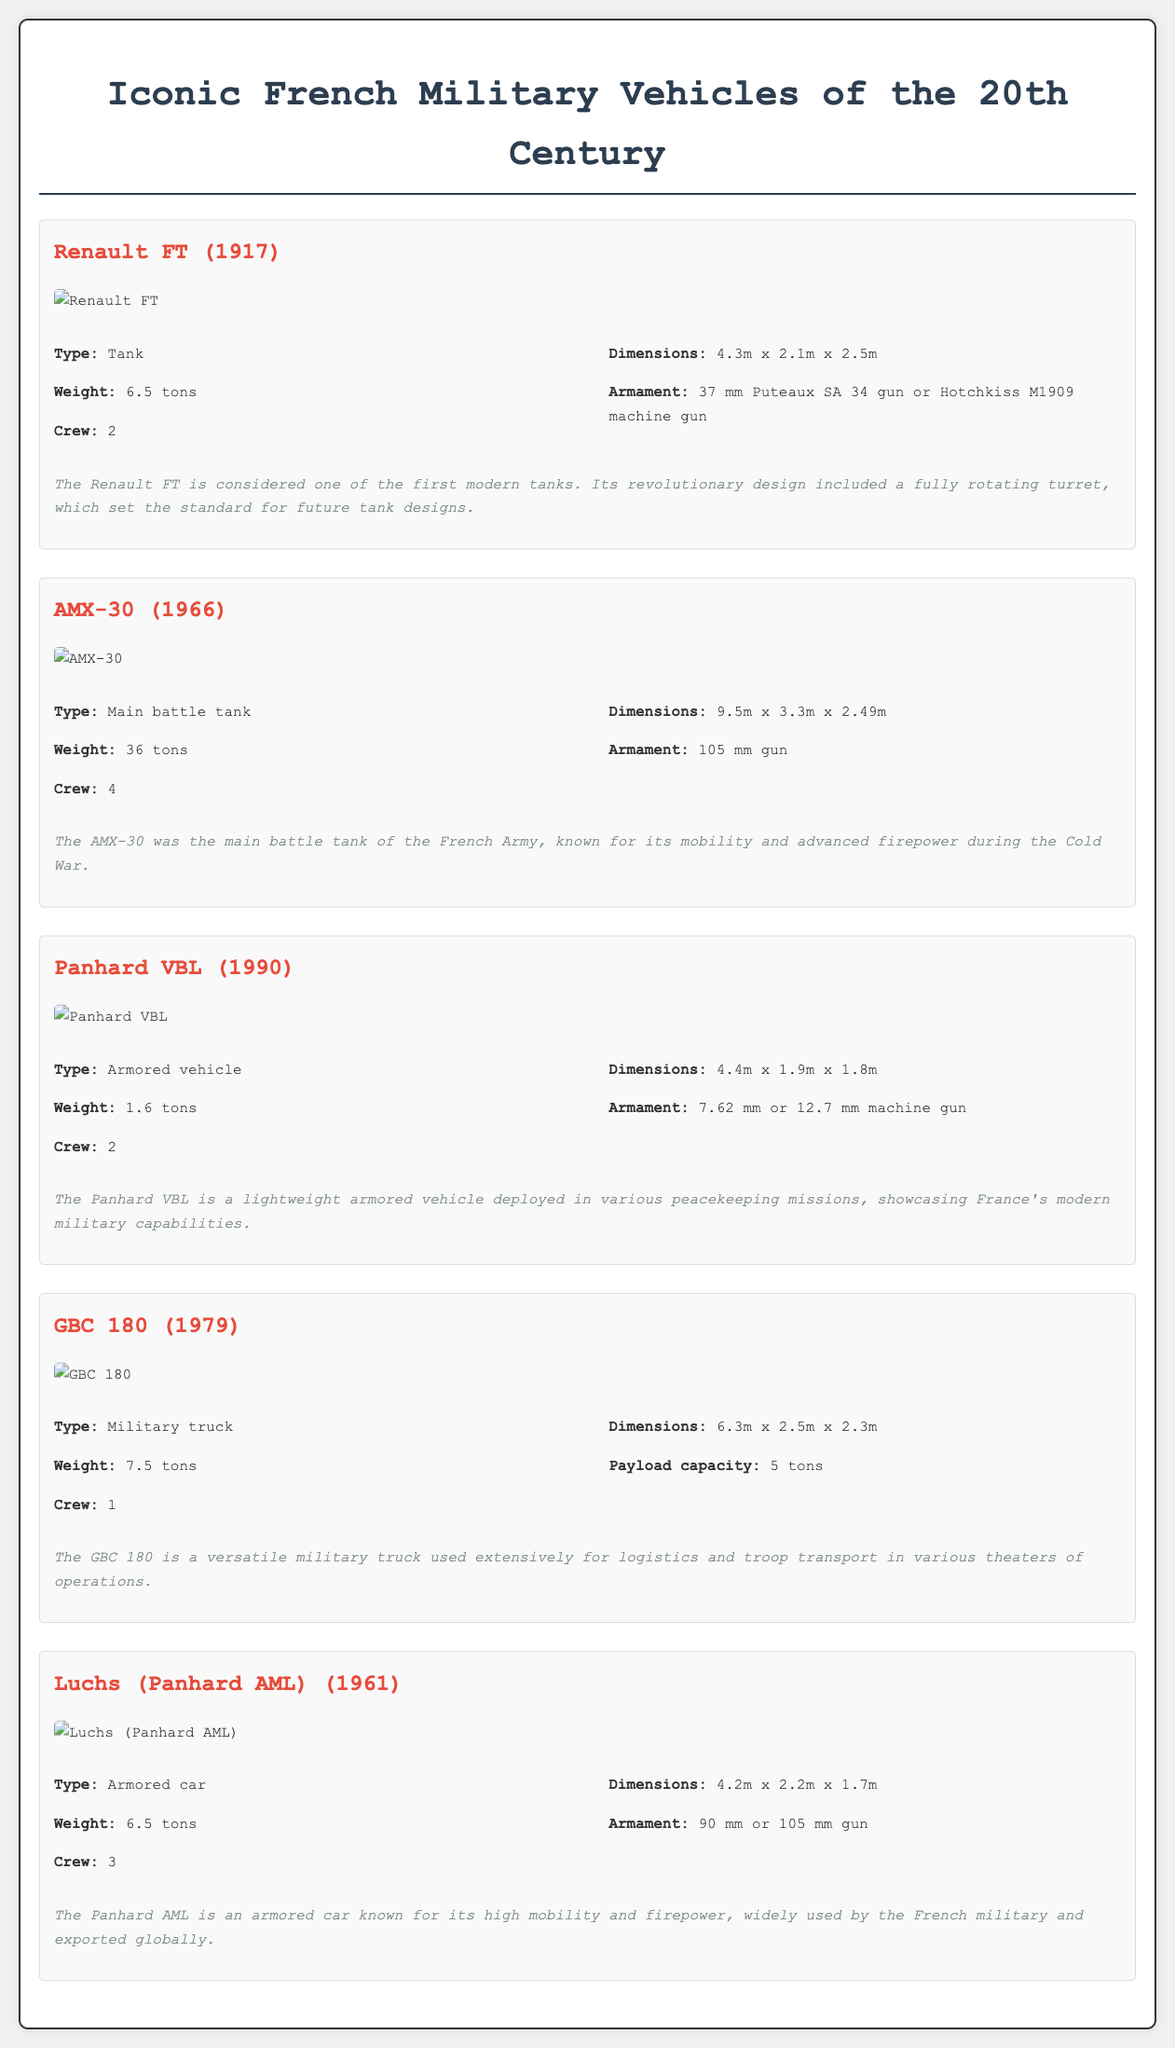What year was the Renault FT introduced? The year of introduction is clearly stated in the section about the Renault FT vehicle.
Answer: 1917 What is the weight of the AMX-30? The weight is specified in the details of the AMX-30 vehicle description.
Answer: 36 tons How many crew members does the Panhard VBL accommodate? The crew capacity is mentioned in the vehicle details for the Panhard VBL.
Answer: 2 What type of vehicle is the GBC 180? The type of vehicle is classified in the description of the GBC 180 section.
Answer: Military truck What is the armament of the Luchs (Panhard AML)? The armament details are provided in the specifications of the Luchs (Panhard AML).
Answer: 90 mm or 105 mm gun Which vehicle is considered one of the first modern tanks? The significance section for the Renault FT discusses its historical importance.
Answer: Renault FT What is the dimensions of the Panhard VBL? The dimensions are listed in the specifications of the Panhard VBL vehicle.
Answer: 4.4m x 1.9m x 1.8m Which military vehicle has a payload capacity of 5 tons? The GBC 180 section specifies its payload capacity.
Answer: GBC 180 